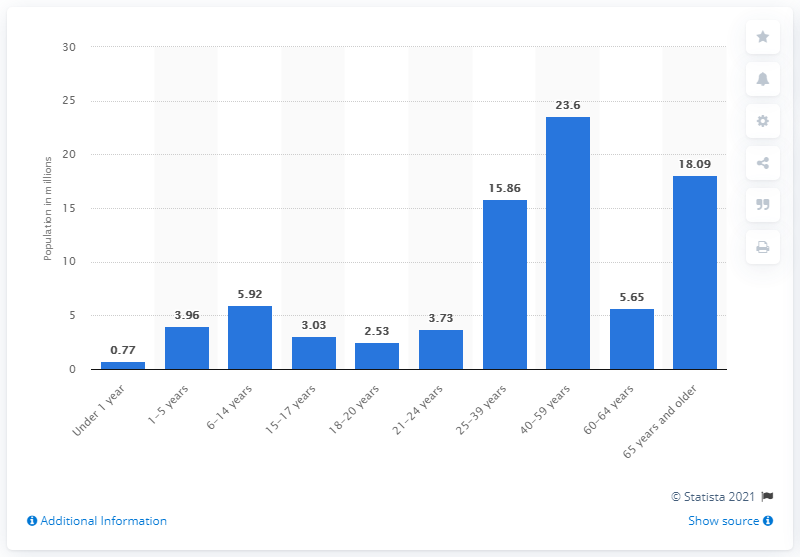Draw attention to some important aspects in this diagram. The largest age group in Germany for individuals aged 65-59 is 65-59-year-olds. The next largest age group in Germany is 65 years and older. In Germany, there are approximately 23.6 million people aged 40-59 years old. 